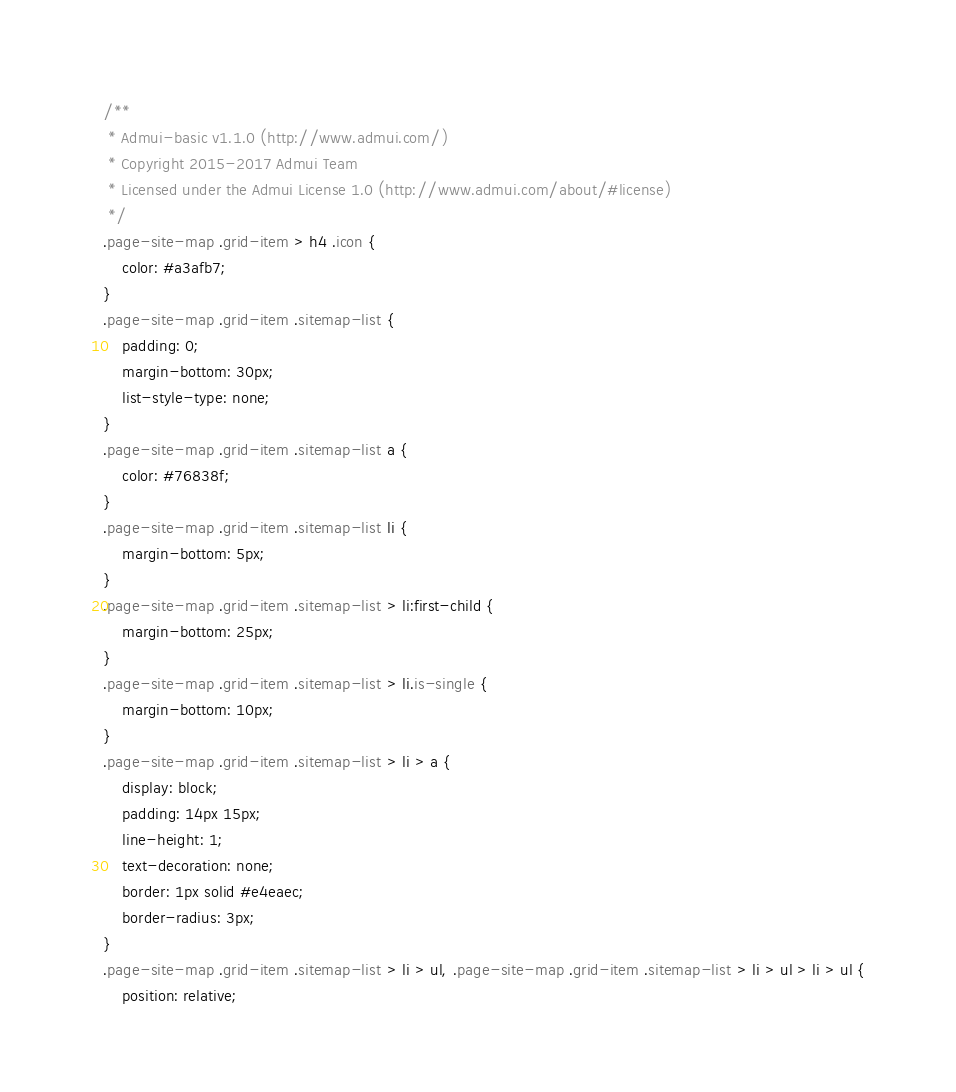<code> <loc_0><loc_0><loc_500><loc_500><_CSS_>/**
 * Admui-basic v1.1.0 (http://www.admui.com/)
 * Copyright 2015-2017 Admui Team
 * Licensed under the Admui License 1.0 (http://www.admui.com/about/#license)
 */
.page-site-map .grid-item > h4 .icon {
	color: #a3afb7;
}
.page-site-map .grid-item .sitemap-list {
	padding: 0;
	margin-bottom: 30px;
	list-style-type: none;
}
.page-site-map .grid-item .sitemap-list a {
	color: #76838f;
}
.page-site-map .grid-item .sitemap-list li {
	margin-bottom: 5px;
}
.page-site-map .grid-item .sitemap-list > li:first-child {
	margin-bottom: 25px;
}
.page-site-map .grid-item .sitemap-list > li.is-single {
	margin-bottom: 10px;
}
.page-site-map .grid-item .sitemap-list > li > a {
	display: block;
	padding: 14px 15px;
	line-height: 1;
	text-decoration: none;
	border: 1px solid #e4eaec;
	border-radius: 3px;
}
.page-site-map .grid-item .sitemap-list > li > ul, .page-site-map .grid-item .sitemap-list > li > ul > li > ul {
	position: relative;</code> 